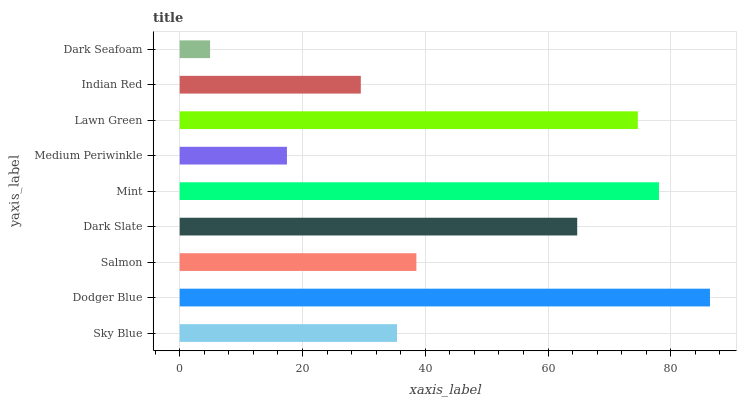Is Dark Seafoam the minimum?
Answer yes or no. Yes. Is Dodger Blue the maximum?
Answer yes or no. Yes. Is Salmon the minimum?
Answer yes or no. No. Is Salmon the maximum?
Answer yes or no. No. Is Dodger Blue greater than Salmon?
Answer yes or no. Yes. Is Salmon less than Dodger Blue?
Answer yes or no. Yes. Is Salmon greater than Dodger Blue?
Answer yes or no. No. Is Dodger Blue less than Salmon?
Answer yes or no. No. Is Salmon the high median?
Answer yes or no. Yes. Is Salmon the low median?
Answer yes or no. Yes. Is Dark Slate the high median?
Answer yes or no. No. Is Lawn Green the low median?
Answer yes or no. No. 